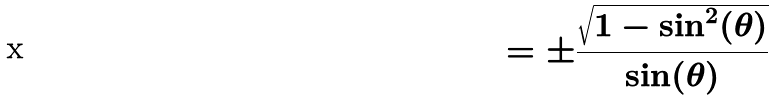Convert formula to latex. <formula><loc_0><loc_0><loc_500><loc_500>= \pm \frac { \sqrt { 1 - \sin ^ { 2 } ( \theta ) } } { \sin ( \theta ) }</formula> 